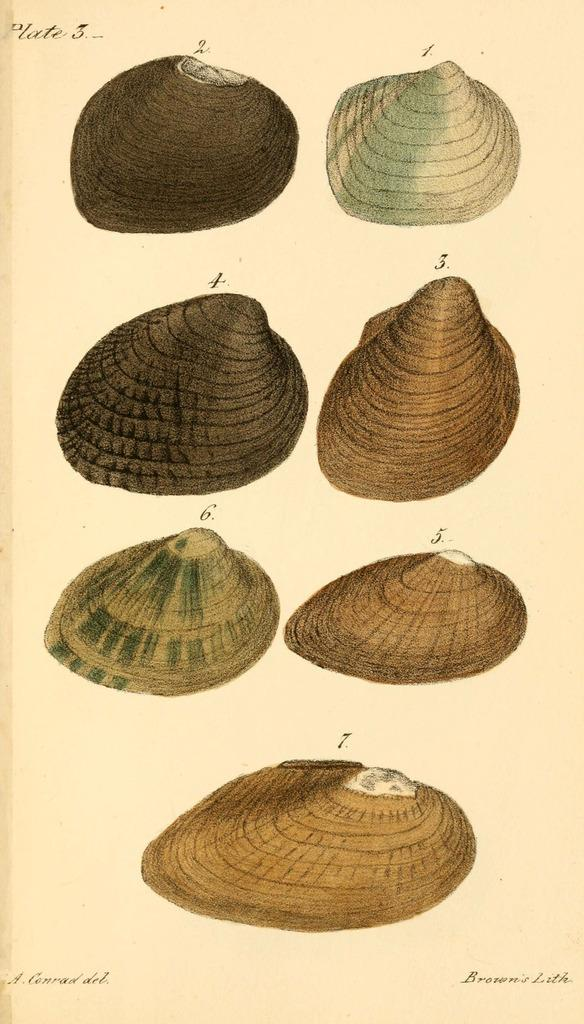What is featured in the image? There is a poster in the image. What is depicted on the poster? The poster contains shells. Are there any words or letters on the poster? Yes, there is text on the poster. How many stockings are hanging from the poster in the image? There are no stockings present in the image; the poster contains shells and text. 